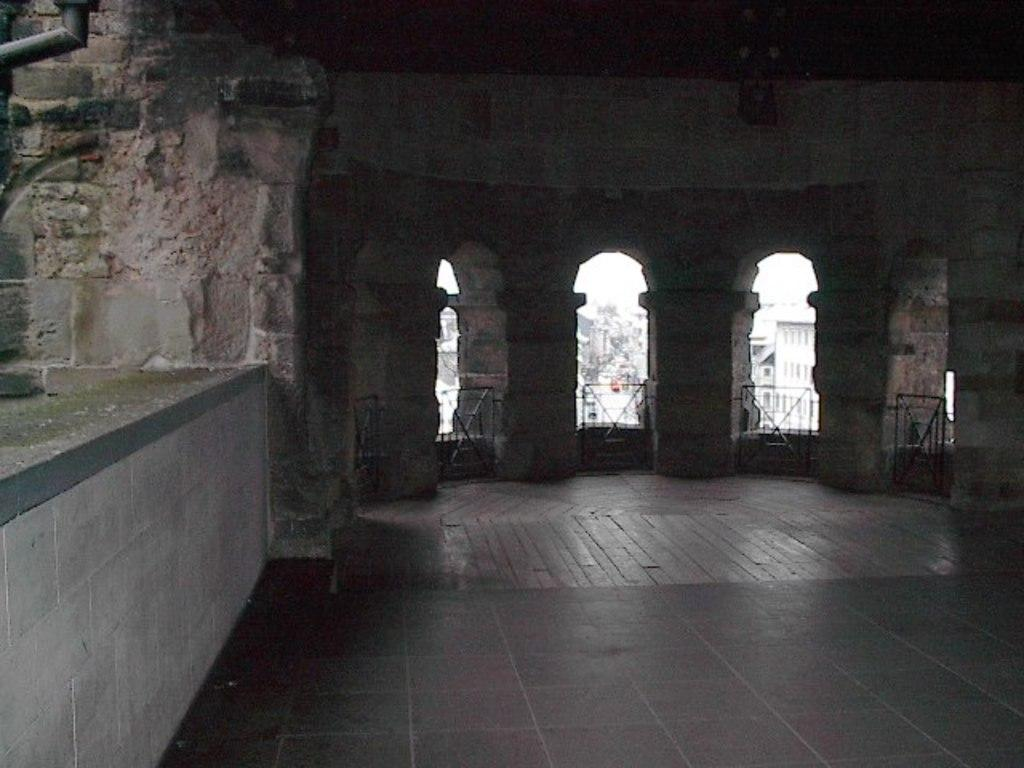Where was the image likely taken? The image was likely taken inside a building. Can you describe the building in the image? The building in the image appears old. What type of fog can be seen in the image? There is no fog present in the image. What type of plantation is visible in the image? There is no plantation present in the image. 